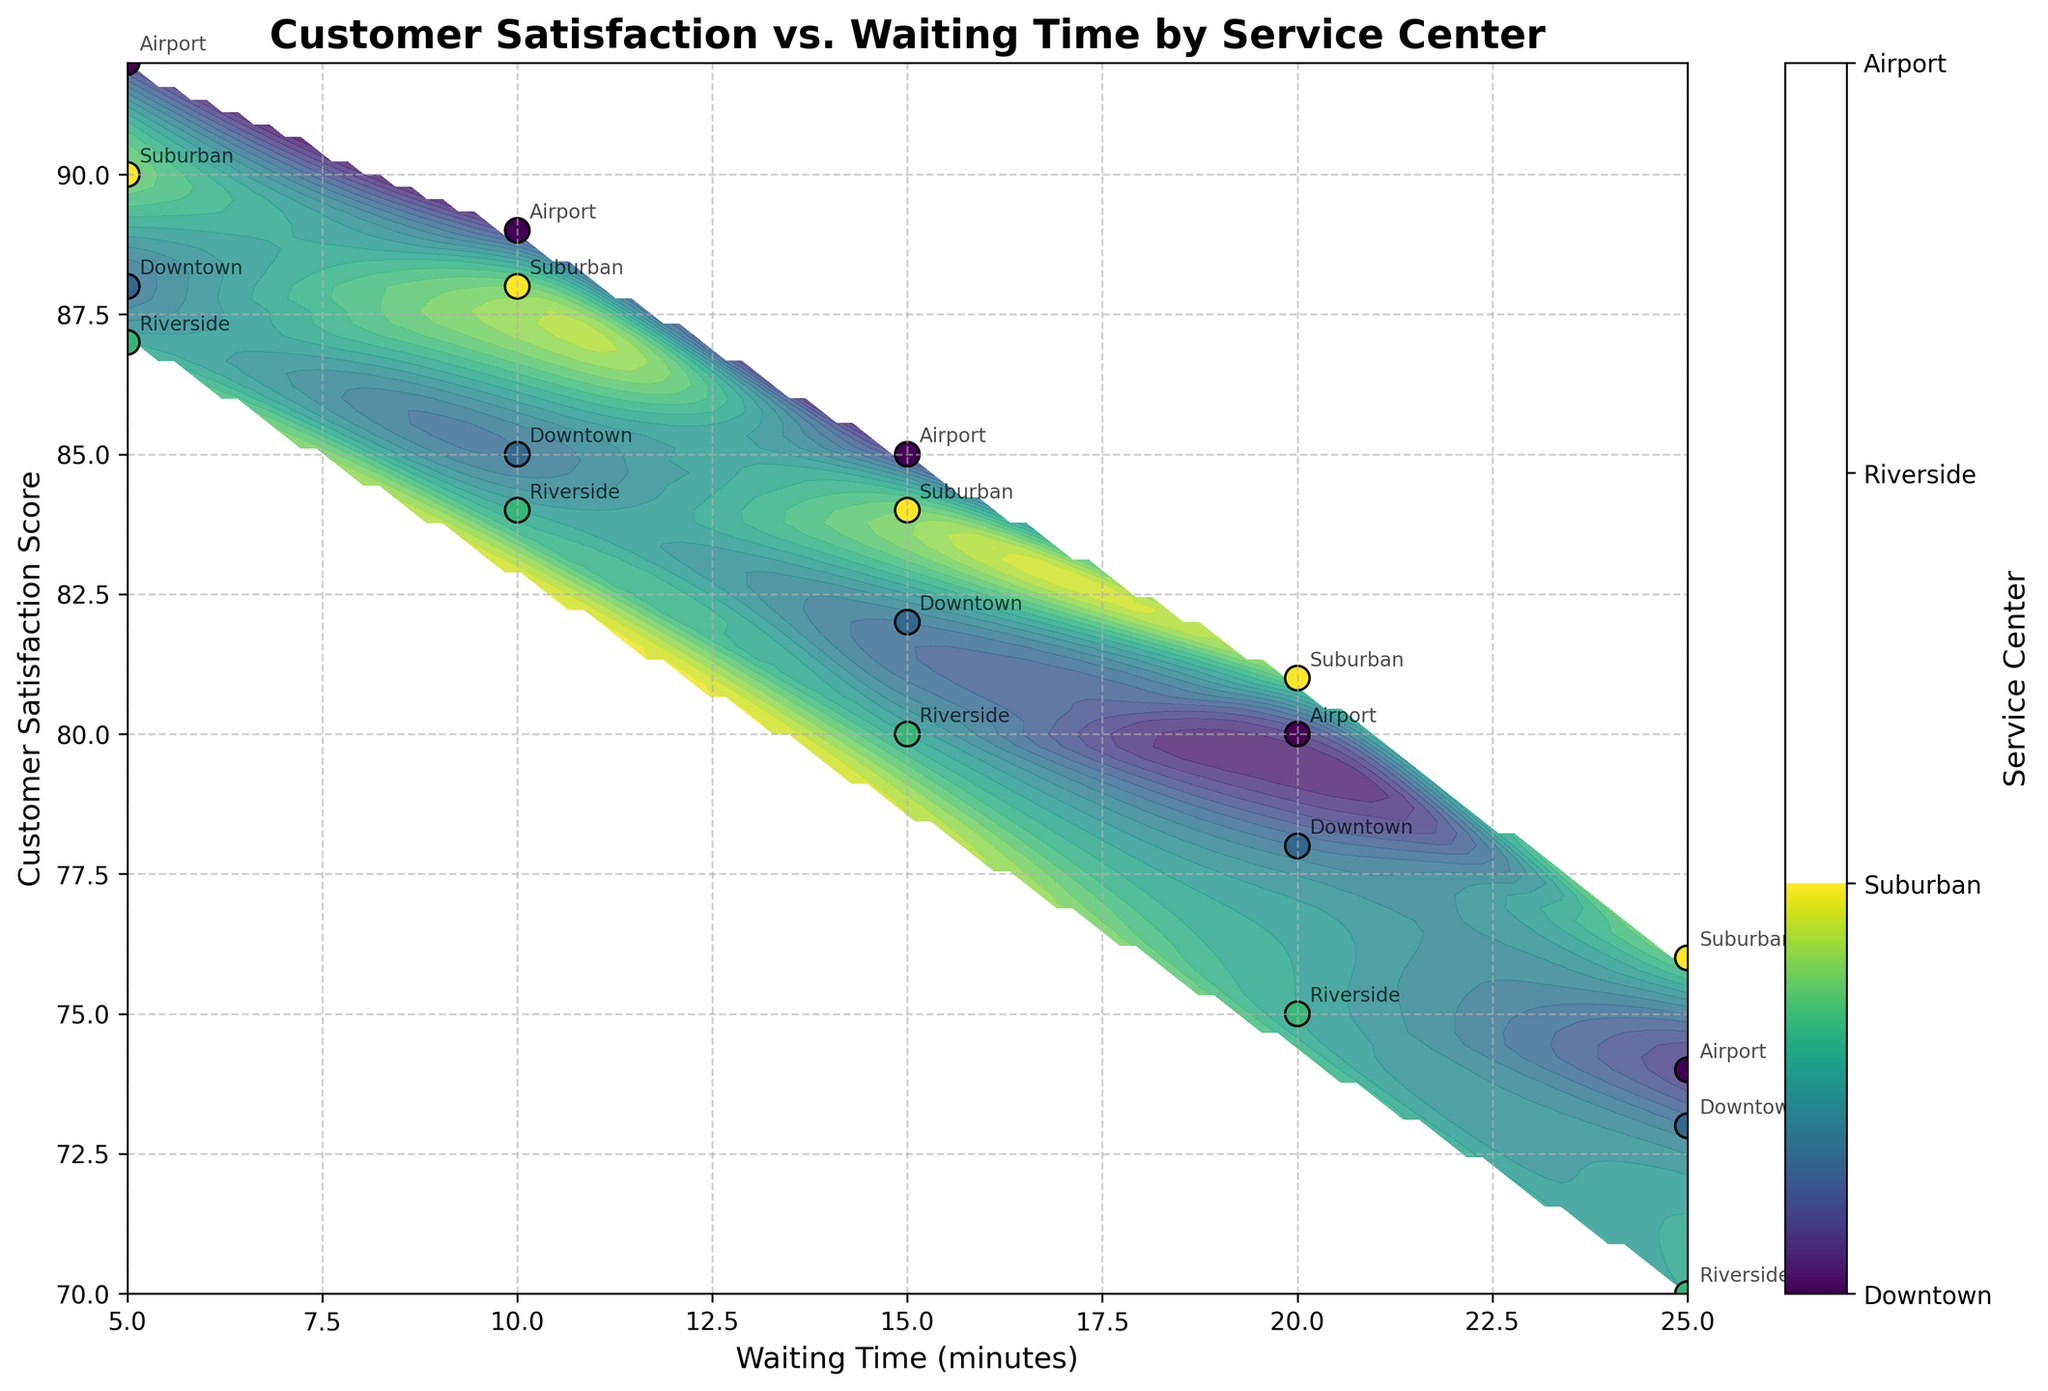What is the title of the figure? The title is usually located at the top of the plot. In this figure, it states the main purpose of the graph, which is to show the relationship between customer satisfaction and waiting time across different service centers.
Answer: Customer Satisfaction vs. Waiting Time by Service Center What is the color range used for the contour plot, and what does it represent? The color range in a contour plot helps represent different values; in this case, it indicates different service centers. Various shades of colors from the 'viridis' colormap are used.
Answer: Different service centers How does customer satisfaction change with waiting time for the Downtown service center? By observing the labels for Downtown, you can see that as the waiting time increases (moves right on the x-axis), the customer satisfaction scores decrease (moves down on the y-axis).
Answer: Decreases Which service center has the highest customer satisfaction score, and what is the corresponding waiting time? Look for the highest point on the customer satisfaction axis and check the annotation label next to it. The highest point is at the Airport service center, at a waiting time of 5 minutes.
Answer: Airport, 5 minutes Which service center generally shows the highest satisfaction scores for waiting times less than 10 minutes? Examine the satisfaction scores for waiting times under 10 minutes and note the labels. The Airport service center shows the highest satisfaction in these instances as its scores are higher than others in the same waiting time range.
Answer: Airport How does the waiting time affect customer satisfaction across different service centers in general? In general, for all service centers, a similar trend can be seen where increasing waiting times lead to decreasing satisfaction scores. This trend is particularly visible across the contour lines and scatter points.
Answer: Decreases Is there any overlap in customer satisfaction scores for different service centers at the same waiting times? Look at the areas in the plot where points from different service centers are close to each other in terms of satisfaction score for a given waiting time. Yes, there are overlaps, especially around waiting times from 10 to 20 minutes.
Answer: Yes What is the difference in customer satisfaction scores between the Airport and Suburban service centers at 15 minutes of waiting time? For 15 minutes of waiting time, identify the scores for both service centers from their annotations. The satisfaction score for Airport is 85, and for Suburban, it is 84. The difference is 85 - 84.
Answer: 1 Which service center has the steepest decline in customer satisfaction as waiting times increase? Compare the slopes of the satisfaction scores for all service centers. The steeper the downward slope, the faster the decline. The Riverside service center shows the steepest decline in satisfaction.
Answer: Riverside 